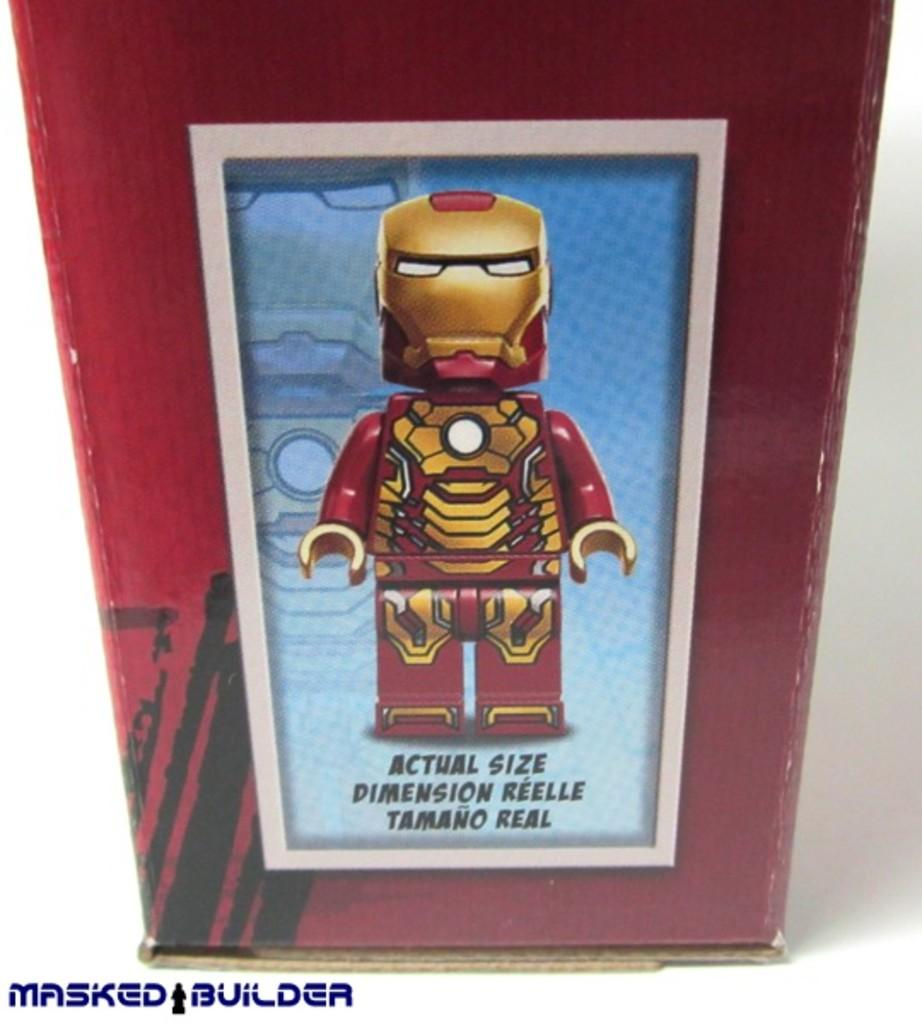<image>
Write a terse but informative summary of the picture. A box that shows the actual size of a masked builder. 